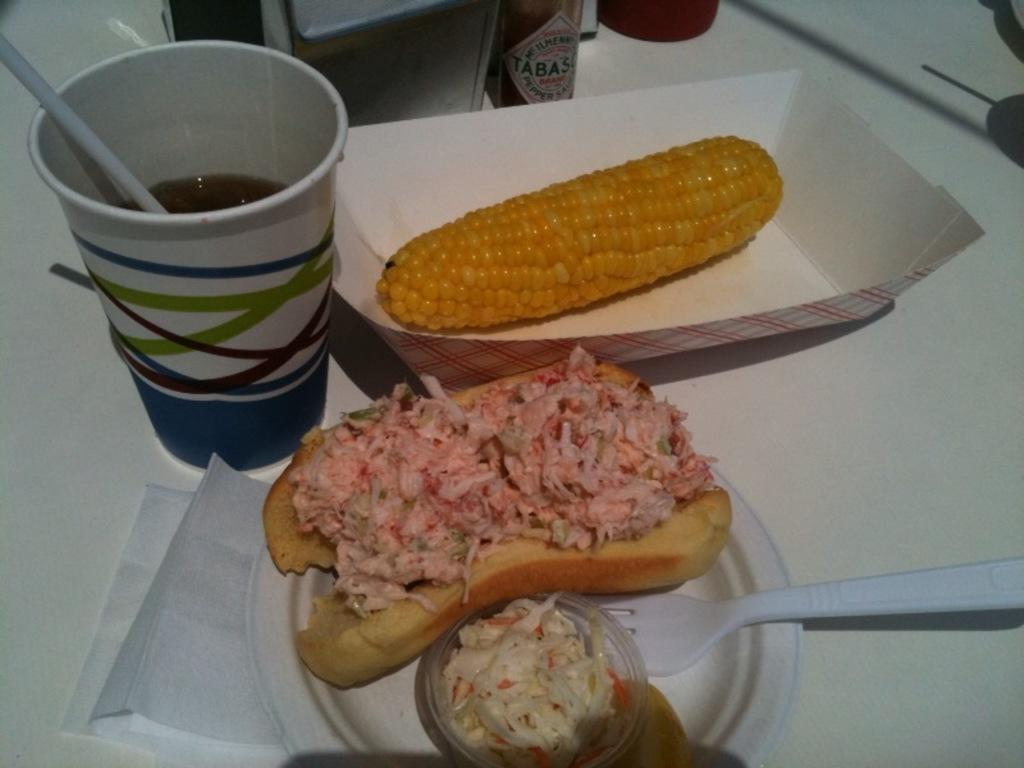What type of food can be seen in the image? There are eatables in the image, including corn and a hot dog. What is the container for a beverage in the image? There is a glass in the image. What utensil is present in the image? There is a fork in the image. What item might be used for cleaning or wiping in the image? There are tissues in the image. What type of pipe can be seen in the image? There is no pipe present in the image. What is located in the middle of the image? The provided facts do not specify a middle point in the image, so it cannot be determined from the information given. 